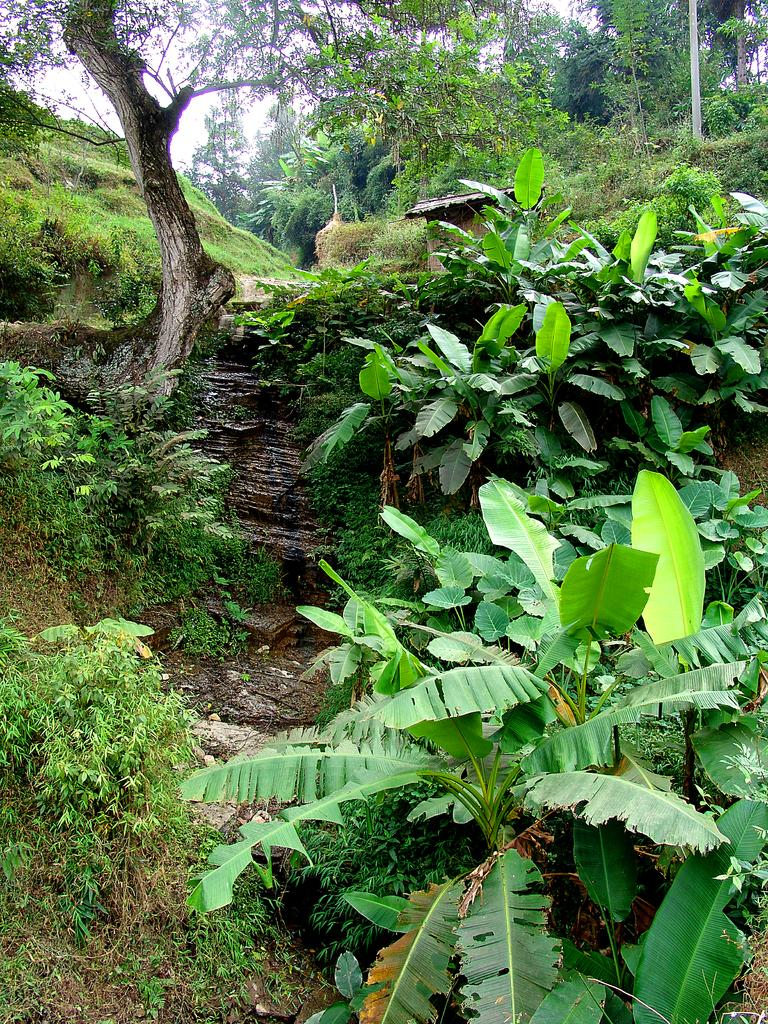What type of vegetation is at the bottom of the image? A: There are plants at the bottom of the image. What can be seen in the background of the image? There are trees in the background of the image. What letter is written on the tree trunk in the image? There is no letter written on the tree trunk in the image. What historical event is depicted in the image? There is no historical event depicted in the image; it features plants and trees. 